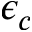<formula> <loc_0><loc_0><loc_500><loc_500>\epsilon _ { c }</formula> 